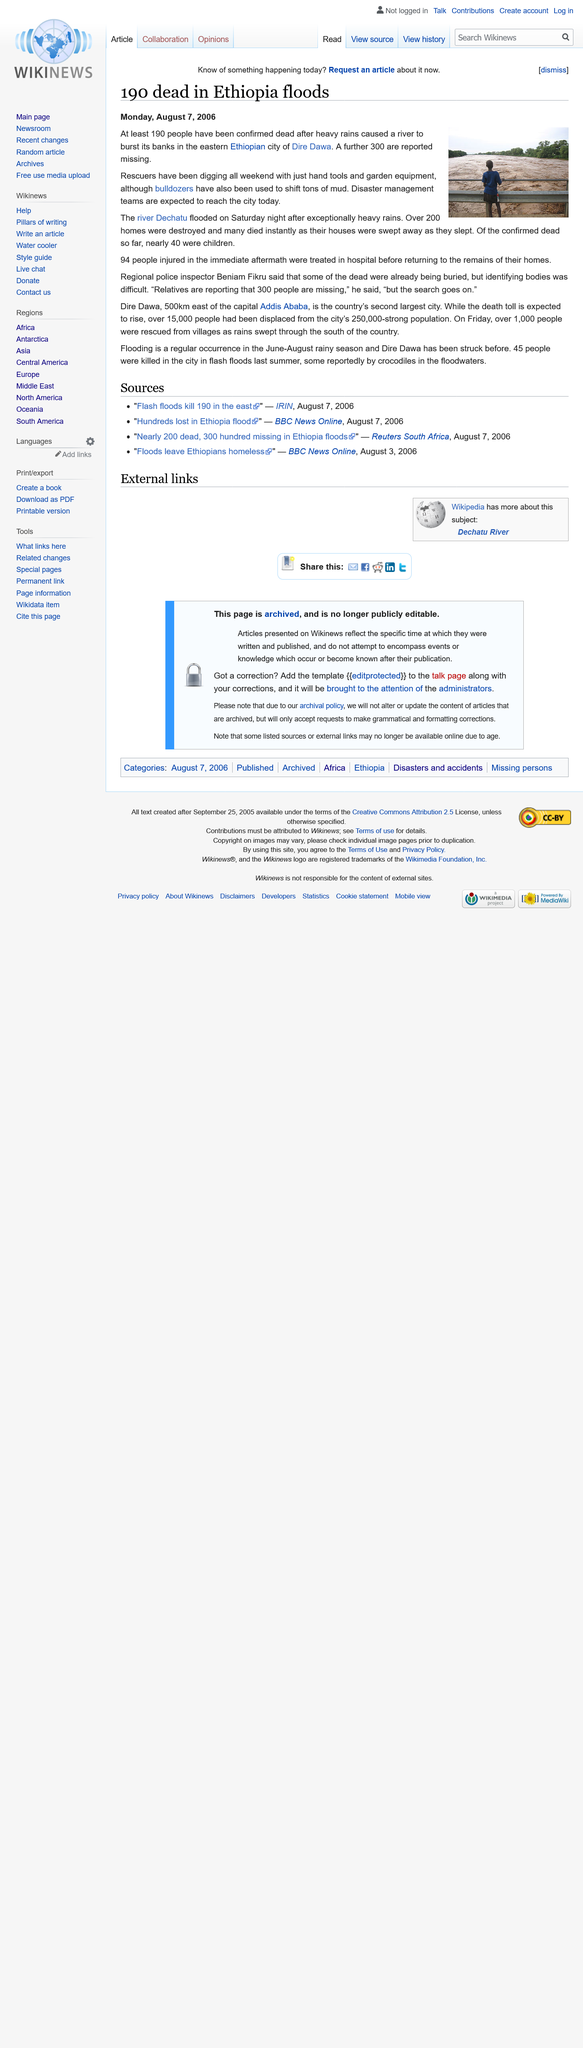Specify some key components in this picture. Bulldozers were used to move tons of mud during the construction process. There were 490 individuals who were either dead or missing in Dire Dawa. The Dechatu river flooded on Saturday, August 5th, 2006. 